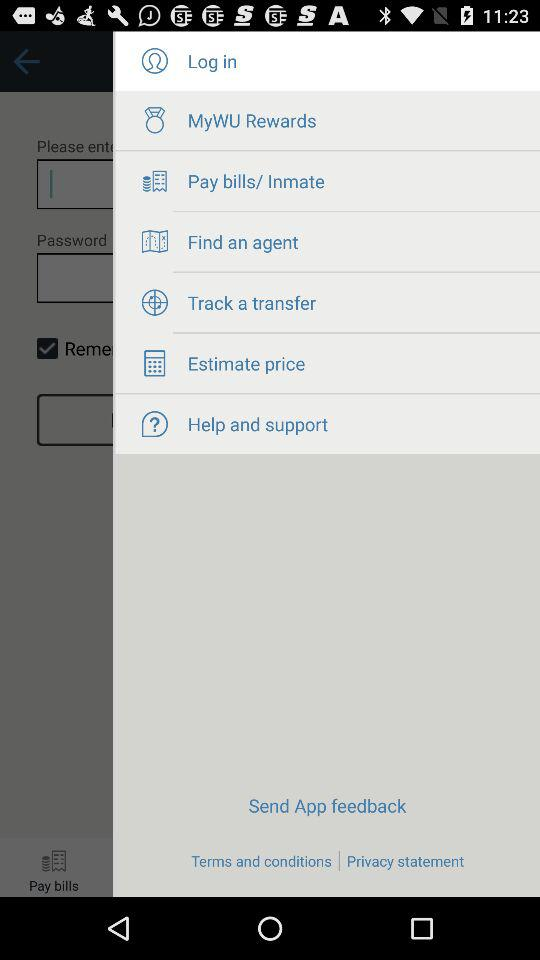What option is selected? The selected option is "Log In". 